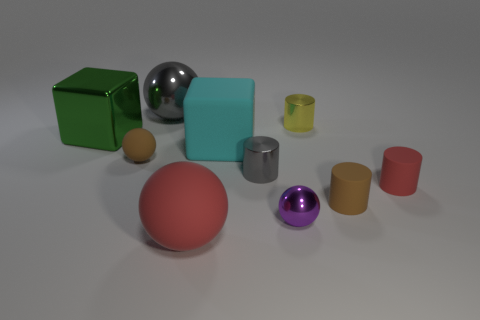Is the size of the gray metal cylinder the same as the matte block?
Give a very brief answer. No. How many tiny matte objects are to the right of the gray object on the left side of the large matte thing behind the tiny brown sphere?
Your answer should be compact. 2. There is a brown object right of the purple thing; what size is it?
Make the answer very short. Small. How many gray cylinders have the same size as the gray metallic ball?
Make the answer very short. 0. There is a green thing; does it have the same size as the brown matte object on the right side of the gray metallic ball?
Provide a short and direct response. No. What number of objects are large purple shiny objects or purple metallic objects?
Your response must be concise. 1. How many tiny rubber cylinders are the same color as the tiny matte sphere?
Your answer should be very brief. 1. What is the shape of the cyan thing that is the same size as the green object?
Provide a short and direct response. Cube. Are there any large matte objects that have the same shape as the large green metallic thing?
Ensure brevity in your answer.  Yes. What number of small red objects have the same material as the big cyan block?
Offer a terse response. 1. 